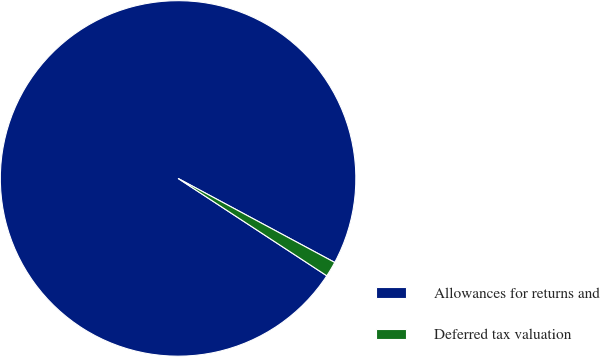Convert chart. <chart><loc_0><loc_0><loc_500><loc_500><pie_chart><fcel>Allowances for returns and<fcel>Deferred tax valuation<nl><fcel>98.61%<fcel>1.39%<nl></chart> 